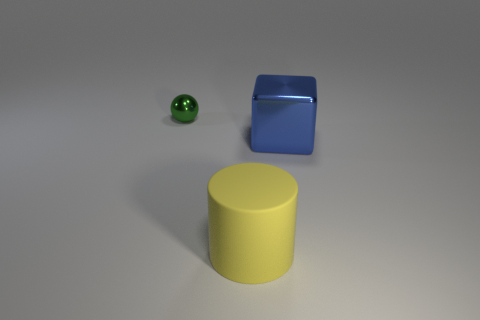Subtract 1 spheres. How many spheres are left? 0 Add 3 big yellow objects. How many objects exist? 6 Subtract all matte cylinders. Subtract all yellow rubber cylinders. How many objects are left? 1 Add 3 large things. How many large things are left? 5 Add 3 rubber objects. How many rubber objects exist? 4 Subtract 1 green balls. How many objects are left? 2 Subtract all gray cubes. Subtract all blue balls. How many cubes are left? 1 